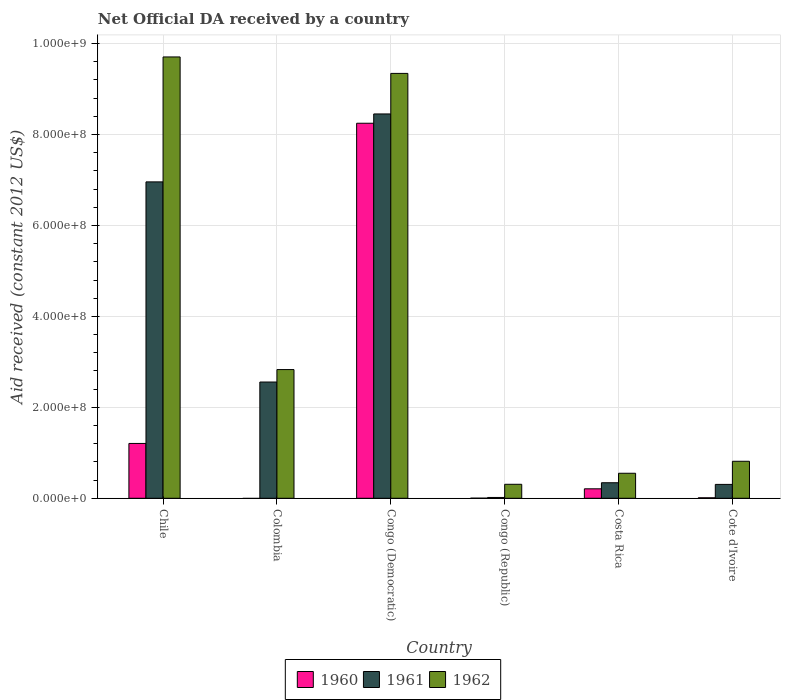Are the number of bars per tick equal to the number of legend labels?
Provide a short and direct response. No. What is the label of the 2nd group of bars from the left?
Ensure brevity in your answer.  Colombia. What is the net official development assistance aid received in 1962 in Colombia?
Keep it short and to the point. 2.83e+08. Across all countries, what is the maximum net official development assistance aid received in 1960?
Ensure brevity in your answer.  8.25e+08. Across all countries, what is the minimum net official development assistance aid received in 1961?
Ensure brevity in your answer.  1.80e+06. In which country was the net official development assistance aid received in 1962 maximum?
Offer a terse response. Chile. What is the total net official development assistance aid received in 1960 in the graph?
Offer a very short reply. 9.68e+08. What is the difference between the net official development assistance aid received in 1962 in Colombia and that in Costa Rica?
Offer a terse response. 2.28e+08. What is the difference between the net official development assistance aid received in 1961 in Chile and the net official development assistance aid received in 1962 in Congo (Democratic)?
Keep it short and to the point. -2.39e+08. What is the average net official development assistance aid received in 1961 per country?
Your answer should be compact. 3.11e+08. What is the difference between the net official development assistance aid received of/in 1962 and net official development assistance aid received of/in 1961 in Colombia?
Offer a terse response. 2.74e+07. What is the ratio of the net official development assistance aid received in 1960 in Congo (Republic) to that in Costa Rica?
Ensure brevity in your answer.  0.01. Is the net official development assistance aid received in 1961 in Congo (Republic) less than that in Cote d'Ivoire?
Keep it short and to the point. Yes. Is the difference between the net official development assistance aid received in 1962 in Colombia and Cote d'Ivoire greater than the difference between the net official development assistance aid received in 1961 in Colombia and Cote d'Ivoire?
Make the answer very short. No. What is the difference between the highest and the second highest net official development assistance aid received in 1961?
Make the answer very short. 5.90e+08. What is the difference between the highest and the lowest net official development assistance aid received in 1961?
Keep it short and to the point. 8.44e+08. How many bars are there?
Your answer should be very brief. 17. How many countries are there in the graph?
Ensure brevity in your answer.  6. Are the values on the major ticks of Y-axis written in scientific E-notation?
Make the answer very short. Yes. Does the graph contain any zero values?
Your response must be concise. Yes. Where does the legend appear in the graph?
Ensure brevity in your answer.  Bottom center. What is the title of the graph?
Provide a succinct answer. Net Official DA received by a country. Does "1995" appear as one of the legend labels in the graph?
Provide a succinct answer. No. What is the label or title of the X-axis?
Provide a succinct answer. Country. What is the label or title of the Y-axis?
Give a very brief answer. Aid received (constant 2012 US$). What is the Aid received (constant 2012 US$) of 1960 in Chile?
Offer a very short reply. 1.21e+08. What is the Aid received (constant 2012 US$) in 1961 in Chile?
Your answer should be compact. 6.96e+08. What is the Aid received (constant 2012 US$) of 1962 in Chile?
Ensure brevity in your answer.  9.71e+08. What is the Aid received (constant 2012 US$) of 1961 in Colombia?
Keep it short and to the point. 2.56e+08. What is the Aid received (constant 2012 US$) of 1962 in Colombia?
Offer a terse response. 2.83e+08. What is the Aid received (constant 2012 US$) of 1960 in Congo (Democratic)?
Provide a short and direct response. 8.25e+08. What is the Aid received (constant 2012 US$) in 1961 in Congo (Democratic)?
Ensure brevity in your answer.  8.45e+08. What is the Aid received (constant 2012 US$) of 1962 in Congo (Democratic)?
Make the answer very short. 9.35e+08. What is the Aid received (constant 2012 US$) of 1960 in Congo (Republic)?
Your answer should be compact. 2.20e+05. What is the Aid received (constant 2012 US$) in 1961 in Congo (Republic)?
Provide a succinct answer. 1.80e+06. What is the Aid received (constant 2012 US$) in 1962 in Congo (Republic)?
Keep it short and to the point. 3.08e+07. What is the Aid received (constant 2012 US$) in 1960 in Costa Rica?
Keep it short and to the point. 2.08e+07. What is the Aid received (constant 2012 US$) of 1961 in Costa Rica?
Your answer should be very brief. 3.42e+07. What is the Aid received (constant 2012 US$) in 1962 in Costa Rica?
Your response must be concise. 5.50e+07. What is the Aid received (constant 2012 US$) in 1960 in Cote d'Ivoire?
Your response must be concise. 1.09e+06. What is the Aid received (constant 2012 US$) in 1961 in Cote d'Ivoire?
Your answer should be compact. 3.05e+07. What is the Aid received (constant 2012 US$) of 1962 in Cote d'Ivoire?
Provide a succinct answer. 8.14e+07. Across all countries, what is the maximum Aid received (constant 2012 US$) in 1960?
Keep it short and to the point. 8.25e+08. Across all countries, what is the maximum Aid received (constant 2012 US$) in 1961?
Provide a short and direct response. 8.45e+08. Across all countries, what is the maximum Aid received (constant 2012 US$) in 1962?
Your answer should be compact. 9.71e+08. Across all countries, what is the minimum Aid received (constant 2012 US$) of 1961?
Give a very brief answer. 1.80e+06. Across all countries, what is the minimum Aid received (constant 2012 US$) of 1962?
Your answer should be compact. 3.08e+07. What is the total Aid received (constant 2012 US$) in 1960 in the graph?
Keep it short and to the point. 9.68e+08. What is the total Aid received (constant 2012 US$) in 1961 in the graph?
Ensure brevity in your answer.  1.86e+09. What is the total Aid received (constant 2012 US$) of 1962 in the graph?
Provide a short and direct response. 2.36e+09. What is the difference between the Aid received (constant 2012 US$) in 1961 in Chile and that in Colombia?
Make the answer very short. 4.40e+08. What is the difference between the Aid received (constant 2012 US$) of 1962 in Chile and that in Colombia?
Make the answer very short. 6.88e+08. What is the difference between the Aid received (constant 2012 US$) of 1960 in Chile and that in Congo (Democratic)?
Ensure brevity in your answer.  -7.04e+08. What is the difference between the Aid received (constant 2012 US$) in 1961 in Chile and that in Congo (Democratic)?
Your response must be concise. -1.49e+08. What is the difference between the Aid received (constant 2012 US$) in 1962 in Chile and that in Congo (Democratic)?
Keep it short and to the point. 3.62e+07. What is the difference between the Aid received (constant 2012 US$) of 1960 in Chile and that in Congo (Republic)?
Provide a short and direct response. 1.20e+08. What is the difference between the Aid received (constant 2012 US$) of 1961 in Chile and that in Congo (Republic)?
Your response must be concise. 6.94e+08. What is the difference between the Aid received (constant 2012 US$) of 1962 in Chile and that in Congo (Republic)?
Your response must be concise. 9.40e+08. What is the difference between the Aid received (constant 2012 US$) of 1960 in Chile and that in Costa Rica?
Make the answer very short. 9.98e+07. What is the difference between the Aid received (constant 2012 US$) in 1961 in Chile and that in Costa Rica?
Ensure brevity in your answer.  6.62e+08. What is the difference between the Aid received (constant 2012 US$) in 1962 in Chile and that in Costa Rica?
Your response must be concise. 9.16e+08. What is the difference between the Aid received (constant 2012 US$) of 1960 in Chile and that in Cote d'Ivoire?
Ensure brevity in your answer.  1.20e+08. What is the difference between the Aid received (constant 2012 US$) of 1961 in Chile and that in Cote d'Ivoire?
Provide a short and direct response. 6.65e+08. What is the difference between the Aid received (constant 2012 US$) in 1962 in Chile and that in Cote d'Ivoire?
Ensure brevity in your answer.  8.89e+08. What is the difference between the Aid received (constant 2012 US$) in 1961 in Colombia and that in Congo (Democratic)?
Offer a terse response. -5.90e+08. What is the difference between the Aid received (constant 2012 US$) in 1962 in Colombia and that in Congo (Democratic)?
Ensure brevity in your answer.  -6.51e+08. What is the difference between the Aid received (constant 2012 US$) in 1961 in Colombia and that in Congo (Republic)?
Your answer should be compact. 2.54e+08. What is the difference between the Aid received (constant 2012 US$) of 1962 in Colombia and that in Congo (Republic)?
Ensure brevity in your answer.  2.52e+08. What is the difference between the Aid received (constant 2012 US$) of 1961 in Colombia and that in Costa Rica?
Give a very brief answer. 2.22e+08. What is the difference between the Aid received (constant 2012 US$) in 1962 in Colombia and that in Costa Rica?
Make the answer very short. 2.28e+08. What is the difference between the Aid received (constant 2012 US$) in 1961 in Colombia and that in Cote d'Ivoire?
Provide a short and direct response. 2.25e+08. What is the difference between the Aid received (constant 2012 US$) of 1962 in Colombia and that in Cote d'Ivoire?
Provide a short and direct response. 2.02e+08. What is the difference between the Aid received (constant 2012 US$) of 1960 in Congo (Democratic) and that in Congo (Republic)?
Provide a succinct answer. 8.25e+08. What is the difference between the Aid received (constant 2012 US$) of 1961 in Congo (Democratic) and that in Congo (Republic)?
Your answer should be compact. 8.44e+08. What is the difference between the Aid received (constant 2012 US$) in 1962 in Congo (Democratic) and that in Congo (Republic)?
Your answer should be very brief. 9.04e+08. What is the difference between the Aid received (constant 2012 US$) in 1960 in Congo (Democratic) and that in Costa Rica?
Keep it short and to the point. 8.04e+08. What is the difference between the Aid received (constant 2012 US$) in 1961 in Congo (Democratic) and that in Costa Rica?
Ensure brevity in your answer.  8.11e+08. What is the difference between the Aid received (constant 2012 US$) of 1962 in Congo (Democratic) and that in Costa Rica?
Your answer should be very brief. 8.79e+08. What is the difference between the Aid received (constant 2012 US$) in 1960 in Congo (Democratic) and that in Cote d'Ivoire?
Ensure brevity in your answer.  8.24e+08. What is the difference between the Aid received (constant 2012 US$) in 1961 in Congo (Democratic) and that in Cote d'Ivoire?
Provide a short and direct response. 8.15e+08. What is the difference between the Aid received (constant 2012 US$) of 1962 in Congo (Democratic) and that in Cote d'Ivoire?
Ensure brevity in your answer.  8.53e+08. What is the difference between the Aid received (constant 2012 US$) in 1960 in Congo (Republic) and that in Costa Rica?
Your answer should be compact. -2.06e+07. What is the difference between the Aid received (constant 2012 US$) in 1961 in Congo (Republic) and that in Costa Rica?
Provide a succinct answer. -3.24e+07. What is the difference between the Aid received (constant 2012 US$) of 1962 in Congo (Republic) and that in Costa Rica?
Provide a short and direct response. -2.42e+07. What is the difference between the Aid received (constant 2012 US$) of 1960 in Congo (Republic) and that in Cote d'Ivoire?
Your response must be concise. -8.70e+05. What is the difference between the Aid received (constant 2012 US$) of 1961 in Congo (Republic) and that in Cote d'Ivoire?
Offer a very short reply. -2.87e+07. What is the difference between the Aid received (constant 2012 US$) of 1962 in Congo (Republic) and that in Cote d'Ivoire?
Offer a terse response. -5.06e+07. What is the difference between the Aid received (constant 2012 US$) in 1960 in Costa Rica and that in Cote d'Ivoire?
Ensure brevity in your answer.  1.97e+07. What is the difference between the Aid received (constant 2012 US$) in 1961 in Costa Rica and that in Cote d'Ivoire?
Your response must be concise. 3.65e+06. What is the difference between the Aid received (constant 2012 US$) of 1962 in Costa Rica and that in Cote d'Ivoire?
Offer a terse response. -2.64e+07. What is the difference between the Aid received (constant 2012 US$) in 1960 in Chile and the Aid received (constant 2012 US$) in 1961 in Colombia?
Offer a terse response. -1.35e+08. What is the difference between the Aid received (constant 2012 US$) in 1960 in Chile and the Aid received (constant 2012 US$) in 1962 in Colombia?
Keep it short and to the point. -1.63e+08. What is the difference between the Aid received (constant 2012 US$) of 1961 in Chile and the Aid received (constant 2012 US$) of 1962 in Colombia?
Provide a short and direct response. 4.13e+08. What is the difference between the Aid received (constant 2012 US$) of 1960 in Chile and the Aid received (constant 2012 US$) of 1961 in Congo (Democratic)?
Provide a short and direct response. -7.25e+08. What is the difference between the Aid received (constant 2012 US$) in 1960 in Chile and the Aid received (constant 2012 US$) in 1962 in Congo (Democratic)?
Offer a very short reply. -8.14e+08. What is the difference between the Aid received (constant 2012 US$) in 1961 in Chile and the Aid received (constant 2012 US$) in 1962 in Congo (Democratic)?
Keep it short and to the point. -2.39e+08. What is the difference between the Aid received (constant 2012 US$) of 1960 in Chile and the Aid received (constant 2012 US$) of 1961 in Congo (Republic)?
Your answer should be compact. 1.19e+08. What is the difference between the Aid received (constant 2012 US$) of 1960 in Chile and the Aid received (constant 2012 US$) of 1962 in Congo (Republic)?
Give a very brief answer. 8.98e+07. What is the difference between the Aid received (constant 2012 US$) in 1961 in Chile and the Aid received (constant 2012 US$) in 1962 in Congo (Republic)?
Make the answer very short. 6.65e+08. What is the difference between the Aid received (constant 2012 US$) in 1960 in Chile and the Aid received (constant 2012 US$) in 1961 in Costa Rica?
Offer a very short reply. 8.64e+07. What is the difference between the Aid received (constant 2012 US$) of 1960 in Chile and the Aid received (constant 2012 US$) of 1962 in Costa Rica?
Keep it short and to the point. 6.56e+07. What is the difference between the Aid received (constant 2012 US$) of 1961 in Chile and the Aid received (constant 2012 US$) of 1962 in Costa Rica?
Make the answer very short. 6.41e+08. What is the difference between the Aid received (constant 2012 US$) in 1960 in Chile and the Aid received (constant 2012 US$) in 1961 in Cote d'Ivoire?
Your answer should be very brief. 9.01e+07. What is the difference between the Aid received (constant 2012 US$) in 1960 in Chile and the Aid received (constant 2012 US$) in 1962 in Cote d'Ivoire?
Make the answer very short. 3.92e+07. What is the difference between the Aid received (constant 2012 US$) in 1961 in Chile and the Aid received (constant 2012 US$) in 1962 in Cote d'Ivoire?
Keep it short and to the point. 6.15e+08. What is the difference between the Aid received (constant 2012 US$) in 1961 in Colombia and the Aid received (constant 2012 US$) in 1962 in Congo (Democratic)?
Your response must be concise. -6.79e+08. What is the difference between the Aid received (constant 2012 US$) of 1961 in Colombia and the Aid received (constant 2012 US$) of 1962 in Congo (Republic)?
Offer a very short reply. 2.25e+08. What is the difference between the Aid received (constant 2012 US$) of 1961 in Colombia and the Aid received (constant 2012 US$) of 1962 in Costa Rica?
Provide a succinct answer. 2.01e+08. What is the difference between the Aid received (constant 2012 US$) of 1961 in Colombia and the Aid received (constant 2012 US$) of 1962 in Cote d'Ivoire?
Provide a short and direct response. 1.74e+08. What is the difference between the Aid received (constant 2012 US$) in 1960 in Congo (Democratic) and the Aid received (constant 2012 US$) in 1961 in Congo (Republic)?
Provide a short and direct response. 8.23e+08. What is the difference between the Aid received (constant 2012 US$) of 1960 in Congo (Democratic) and the Aid received (constant 2012 US$) of 1962 in Congo (Republic)?
Give a very brief answer. 7.94e+08. What is the difference between the Aid received (constant 2012 US$) of 1961 in Congo (Democratic) and the Aid received (constant 2012 US$) of 1962 in Congo (Republic)?
Your response must be concise. 8.15e+08. What is the difference between the Aid received (constant 2012 US$) in 1960 in Congo (Democratic) and the Aid received (constant 2012 US$) in 1961 in Costa Rica?
Your answer should be compact. 7.91e+08. What is the difference between the Aid received (constant 2012 US$) in 1960 in Congo (Democratic) and the Aid received (constant 2012 US$) in 1962 in Costa Rica?
Ensure brevity in your answer.  7.70e+08. What is the difference between the Aid received (constant 2012 US$) of 1961 in Congo (Democratic) and the Aid received (constant 2012 US$) of 1962 in Costa Rica?
Offer a very short reply. 7.90e+08. What is the difference between the Aid received (constant 2012 US$) of 1960 in Congo (Democratic) and the Aid received (constant 2012 US$) of 1961 in Cote d'Ivoire?
Give a very brief answer. 7.94e+08. What is the difference between the Aid received (constant 2012 US$) of 1960 in Congo (Democratic) and the Aid received (constant 2012 US$) of 1962 in Cote d'Ivoire?
Provide a succinct answer. 7.43e+08. What is the difference between the Aid received (constant 2012 US$) of 1961 in Congo (Democratic) and the Aid received (constant 2012 US$) of 1962 in Cote d'Ivoire?
Your response must be concise. 7.64e+08. What is the difference between the Aid received (constant 2012 US$) of 1960 in Congo (Republic) and the Aid received (constant 2012 US$) of 1961 in Costa Rica?
Provide a succinct answer. -3.40e+07. What is the difference between the Aid received (constant 2012 US$) of 1960 in Congo (Republic) and the Aid received (constant 2012 US$) of 1962 in Costa Rica?
Ensure brevity in your answer.  -5.48e+07. What is the difference between the Aid received (constant 2012 US$) of 1961 in Congo (Republic) and the Aid received (constant 2012 US$) of 1962 in Costa Rica?
Offer a very short reply. -5.32e+07. What is the difference between the Aid received (constant 2012 US$) of 1960 in Congo (Republic) and the Aid received (constant 2012 US$) of 1961 in Cote d'Ivoire?
Your answer should be compact. -3.03e+07. What is the difference between the Aid received (constant 2012 US$) of 1960 in Congo (Republic) and the Aid received (constant 2012 US$) of 1962 in Cote d'Ivoire?
Provide a succinct answer. -8.12e+07. What is the difference between the Aid received (constant 2012 US$) in 1961 in Congo (Republic) and the Aid received (constant 2012 US$) in 1962 in Cote d'Ivoire?
Your response must be concise. -7.96e+07. What is the difference between the Aid received (constant 2012 US$) in 1960 in Costa Rica and the Aid received (constant 2012 US$) in 1961 in Cote d'Ivoire?
Keep it short and to the point. -9.71e+06. What is the difference between the Aid received (constant 2012 US$) of 1960 in Costa Rica and the Aid received (constant 2012 US$) of 1962 in Cote d'Ivoire?
Keep it short and to the point. -6.06e+07. What is the difference between the Aid received (constant 2012 US$) of 1961 in Costa Rica and the Aid received (constant 2012 US$) of 1962 in Cote d'Ivoire?
Make the answer very short. -4.72e+07. What is the average Aid received (constant 2012 US$) of 1960 per country?
Give a very brief answer. 1.61e+08. What is the average Aid received (constant 2012 US$) in 1961 per country?
Offer a terse response. 3.11e+08. What is the average Aid received (constant 2012 US$) of 1962 per country?
Your response must be concise. 3.93e+08. What is the difference between the Aid received (constant 2012 US$) in 1960 and Aid received (constant 2012 US$) in 1961 in Chile?
Ensure brevity in your answer.  -5.75e+08. What is the difference between the Aid received (constant 2012 US$) of 1960 and Aid received (constant 2012 US$) of 1962 in Chile?
Offer a very short reply. -8.50e+08. What is the difference between the Aid received (constant 2012 US$) of 1961 and Aid received (constant 2012 US$) of 1962 in Chile?
Provide a succinct answer. -2.75e+08. What is the difference between the Aid received (constant 2012 US$) in 1961 and Aid received (constant 2012 US$) in 1962 in Colombia?
Provide a succinct answer. -2.74e+07. What is the difference between the Aid received (constant 2012 US$) of 1960 and Aid received (constant 2012 US$) of 1961 in Congo (Democratic)?
Provide a succinct answer. -2.05e+07. What is the difference between the Aid received (constant 2012 US$) in 1960 and Aid received (constant 2012 US$) in 1962 in Congo (Democratic)?
Your answer should be compact. -1.10e+08. What is the difference between the Aid received (constant 2012 US$) of 1961 and Aid received (constant 2012 US$) of 1962 in Congo (Democratic)?
Your response must be concise. -8.92e+07. What is the difference between the Aid received (constant 2012 US$) in 1960 and Aid received (constant 2012 US$) in 1961 in Congo (Republic)?
Your answer should be very brief. -1.58e+06. What is the difference between the Aid received (constant 2012 US$) in 1960 and Aid received (constant 2012 US$) in 1962 in Congo (Republic)?
Offer a terse response. -3.06e+07. What is the difference between the Aid received (constant 2012 US$) of 1961 and Aid received (constant 2012 US$) of 1962 in Congo (Republic)?
Ensure brevity in your answer.  -2.90e+07. What is the difference between the Aid received (constant 2012 US$) of 1960 and Aid received (constant 2012 US$) of 1961 in Costa Rica?
Give a very brief answer. -1.34e+07. What is the difference between the Aid received (constant 2012 US$) in 1960 and Aid received (constant 2012 US$) in 1962 in Costa Rica?
Keep it short and to the point. -3.42e+07. What is the difference between the Aid received (constant 2012 US$) in 1961 and Aid received (constant 2012 US$) in 1962 in Costa Rica?
Offer a very short reply. -2.08e+07. What is the difference between the Aid received (constant 2012 US$) of 1960 and Aid received (constant 2012 US$) of 1961 in Cote d'Ivoire?
Ensure brevity in your answer.  -2.94e+07. What is the difference between the Aid received (constant 2012 US$) of 1960 and Aid received (constant 2012 US$) of 1962 in Cote d'Ivoire?
Offer a very short reply. -8.03e+07. What is the difference between the Aid received (constant 2012 US$) of 1961 and Aid received (constant 2012 US$) of 1962 in Cote d'Ivoire?
Offer a very short reply. -5.09e+07. What is the ratio of the Aid received (constant 2012 US$) of 1961 in Chile to that in Colombia?
Provide a short and direct response. 2.72. What is the ratio of the Aid received (constant 2012 US$) in 1962 in Chile to that in Colombia?
Your answer should be compact. 3.43. What is the ratio of the Aid received (constant 2012 US$) of 1960 in Chile to that in Congo (Democratic)?
Offer a terse response. 0.15. What is the ratio of the Aid received (constant 2012 US$) of 1961 in Chile to that in Congo (Democratic)?
Your answer should be very brief. 0.82. What is the ratio of the Aid received (constant 2012 US$) in 1962 in Chile to that in Congo (Democratic)?
Your response must be concise. 1.04. What is the ratio of the Aid received (constant 2012 US$) in 1960 in Chile to that in Congo (Republic)?
Provide a short and direct response. 548.18. What is the ratio of the Aid received (constant 2012 US$) of 1961 in Chile to that in Congo (Republic)?
Offer a very short reply. 386.62. What is the ratio of the Aid received (constant 2012 US$) in 1962 in Chile to that in Congo (Republic)?
Provide a short and direct response. 31.54. What is the ratio of the Aid received (constant 2012 US$) in 1960 in Chile to that in Costa Rica?
Keep it short and to the point. 5.79. What is the ratio of the Aid received (constant 2012 US$) in 1961 in Chile to that in Costa Rica?
Offer a very short reply. 20.35. What is the ratio of the Aid received (constant 2012 US$) in 1962 in Chile to that in Costa Rica?
Provide a short and direct response. 17.64. What is the ratio of the Aid received (constant 2012 US$) in 1960 in Chile to that in Cote d'Ivoire?
Your answer should be compact. 110.64. What is the ratio of the Aid received (constant 2012 US$) of 1961 in Chile to that in Cote d'Ivoire?
Your response must be concise. 22.79. What is the ratio of the Aid received (constant 2012 US$) of 1962 in Chile to that in Cote d'Ivoire?
Your response must be concise. 11.92. What is the ratio of the Aid received (constant 2012 US$) in 1961 in Colombia to that in Congo (Democratic)?
Your response must be concise. 0.3. What is the ratio of the Aid received (constant 2012 US$) of 1962 in Colombia to that in Congo (Democratic)?
Ensure brevity in your answer.  0.3. What is the ratio of the Aid received (constant 2012 US$) in 1961 in Colombia to that in Congo (Republic)?
Make the answer very short. 142.05. What is the ratio of the Aid received (constant 2012 US$) of 1962 in Colombia to that in Congo (Republic)?
Your response must be concise. 9.2. What is the ratio of the Aid received (constant 2012 US$) in 1961 in Colombia to that in Costa Rica?
Provide a succinct answer. 7.48. What is the ratio of the Aid received (constant 2012 US$) in 1962 in Colombia to that in Costa Rica?
Provide a short and direct response. 5.15. What is the ratio of the Aid received (constant 2012 US$) in 1961 in Colombia to that in Cote d'Ivoire?
Ensure brevity in your answer.  8.37. What is the ratio of the Aid received (constant 2012 US$) in 1962 in Colombia to that in Cote d'Ivoire?
Your answer should be very brief. 3.48. What is the ratio of the Aid received (constant 2012 US$) in 1960 in Congo (Democratic) to that in Congo (Republic)?
Provide a succinct answer. 3749.45. What is the ratio of the Aid received (constant 2012 US$) of 1961 in Congo (Democratic) to that in Congo (Republic)?
Your response must be concise. 469.64. What is the ratio of the Aid received (constant 2012 US$) of 1962 in Congo (Democratic) to that in Congo (Republic)?
Give a very brief answer. 30.36. What is the ratio of the Aid received (constant 2012 US$) of 1960 in Congo (Democratic) to that in Costa Rica?
Make the answer very short. 39.6. What is the ratio of the Aid received (constant 2012 US$) of 1961 in Congo (Democratic) to that in Costa Rica?
Offer a terse response. 24.73. What is the ratio of the Aid received (constant 2012 US$) in 1962 in Congo (Democratic) to that in Costa Rica?
Your answer should be very brief. 16.98. What is the ratio of the Aid received (constant 2012 US$) in 1960 in Congo (Democratic) to that in Cote d'Ivoire?
Your response must be concise. 756.77. What is the ratio of the Aid received (constant 2012 US$) in 1961 in Congo (Democratic) to that in Cote d'Ivoire?
Provide a short and direct response. 27.68. What is the ratio of the Aid received (constant 2012 US$) of 1962 in Congo (Democratic) to that in Cote d'Ivoire?
Give a very brief answer. 11.48. What is the ratio of the Aid received (constant 2012 US$) of 1960 in Congo (Republic) to that in Costa Rica?
Provide a succinct answer. 0.01. What is the ratio of the Aid received (constant 2012 US$) of 1961 in Congo (Republic) to that in Costa Rica?
Make the answer very short. 0.05. What is the ratio of the Aid received (constant 2012 US$) in 1962 in Congo (Republic) to that in Costa Rica?
Your response must be concise. 0.56. What is the ratio of the Aid received (constant 2012 US$) in 1960 in Congo (Republic) to that in Cote d'Ivoire?
Make the answer very short. 0.2. What is the ratio of the Aid received (constant 2012 US$) in 1961 in Congo (Republic) to that in Cote d'Ivoire?
Ensure brevity in your answer.  0.06. What is the ratio of the Aid received (constant 2012 US$) of 1962 in Congo (Republic) to that in Cote d'Ivoire?
Make the answer very short. 0.38. What is the ratio of the Aid received (constant 2012 US$) in 1960 in Costa Rica to that in Cote d'Ivoire?
Give a very brief answer. 19.11. What is the ratio of the Aid received (constant 2012 US$) of 1961 in Costa Rica to that in Cote d'Ivoire?
Offer a very short reply. 1.12. What is the ratio of the Aid received (constant 2012 US$) in 1962 in Costa Rica to that in Cote d'Ivoire?
Provide a succinct answer. 0.68. What is the difference between the highest and the second highest Aid received (constant 2012 US$) of 1960?
Your response must be concise. 7.04e+08. What is the difference between the highest and the second highest Aid received (constant 2012 US$) in 1961?
Give a very brief answer. 1.49e+08. What is the difference between the highest and the second highest Aid received (constant 2012 US$) of 1962?
Provide a succinct answer. 3.62e+07. What is the difference between the highest and the lowest Aid received (constant 2012 US$) in 1960?
Offer a very short reply. 8.25e+08. What is the difference between the highest and the lowest Aid received (constant 2012 US$) in 1961?
Give a very brief answer. 8.44e+08. What is the difference between the highest and the lowest Aid received (constant 2012 US$) of 1962?
Keep it short and to the point. 9.40e+08. 